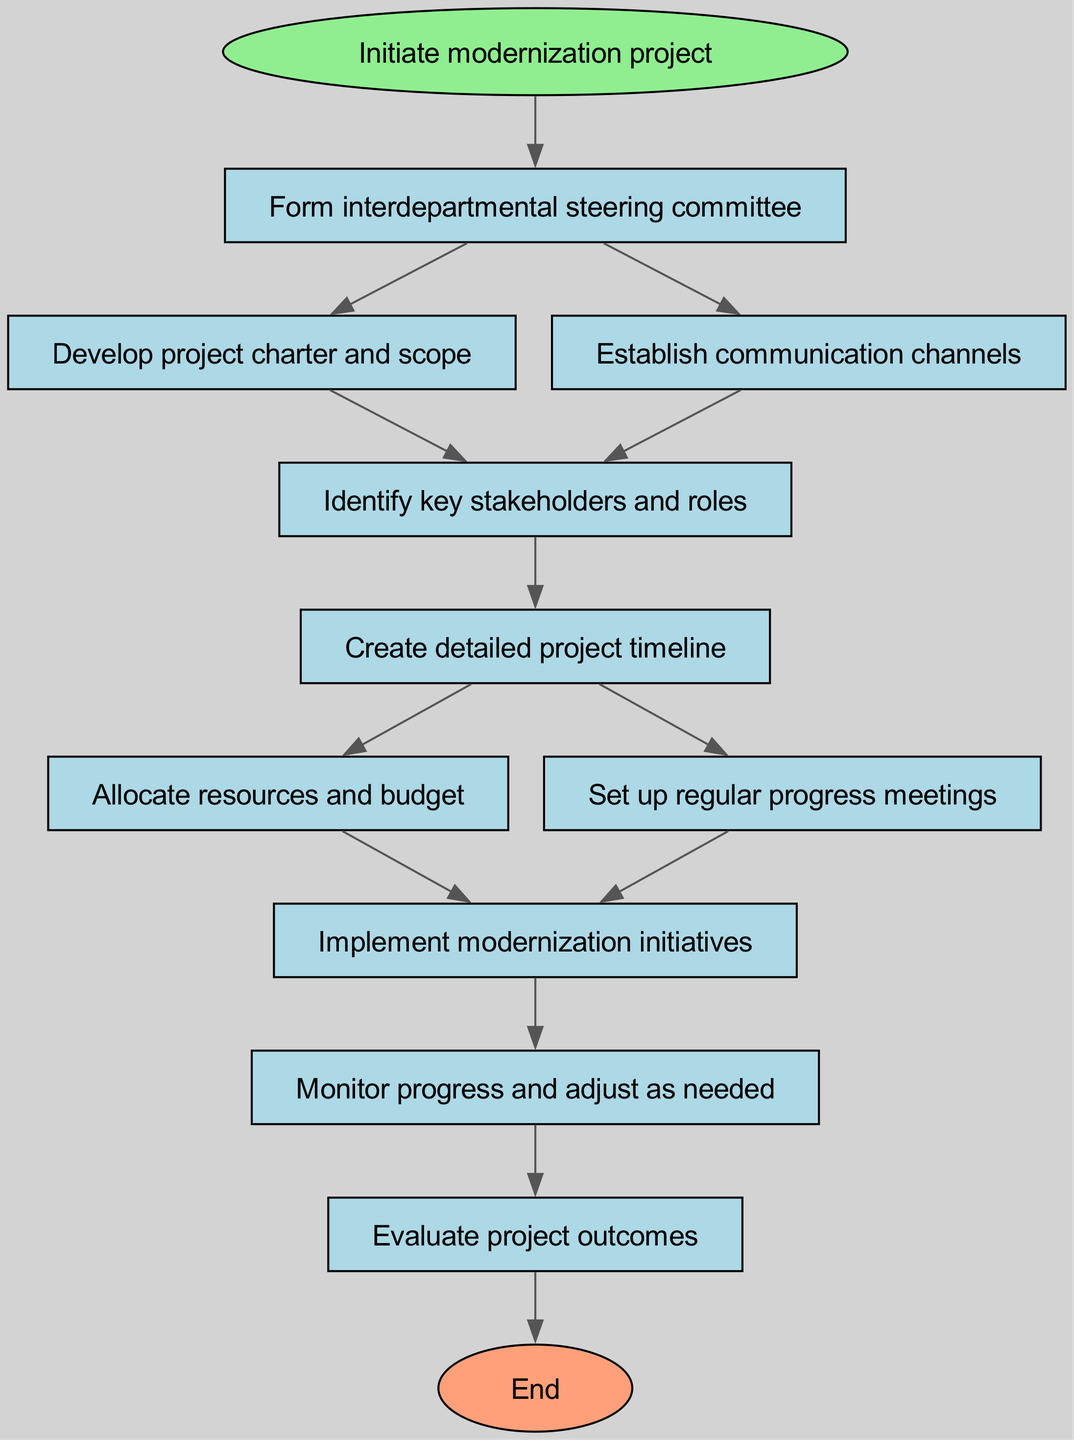What's the first step in the process? The diagram begins with the node labeled "Initiate modernization project," which represents the initial action taken in the protocol. Thus, the first step is to initiate the project.
Answer: Initiate modernization project How many nodes are in this diagram? The diagram contains a total of 10 process nodes and an additional start and end node, making it 12 nodes in total.
Answer: 12 nodes Which step follows the establishment of communication channels? According to the flowchart, the next step that follows "Establish communication channels" is "Identify key stakeholders and roles." The flow moves directly from step 3 to step 4.
Answer: Identify key stakeholders and roles What is the last action in the protocol? The last action in the diagram is represented by the node "Evaluate project outcomes," which is the final step before concluding the process.
Answer: Evaluate project outcomes How many next steps are there from creating a detailed project timeline? The diagram indicates that from the "Create detailed project timeline" node, there are two next steps, which are "Allocate resources and budget" and "Set up regular progress meetings."
Answer: 2 next steps Which nodes are directly connected from the form interdepartmental steering committee step? The "Form interdepartmental steering committee" step directly connects to two nodes: "Develop project charter and scope" and "Establish communication channels." These are the immediate next steps from this action.
Answer: Develop project charter and scope, Establish communication channels How do the regular progress meetings contribute to the project? "Set up regular progress meetings" is a step that leads to the implementation phase. These meetings are vital for maintaining oversight during "Implement modernization initiatives," ensuring the project stays on track.
Answer: Maintain oversight What is necessary before implementing modernization initiatives? Before "Implement modernization initiatives," stakeholders must "Identify key stakeholders and roles." This step is crucial for ensuring that the right people are involved in the implementation process.
Answer: Identify key stakeholders and roles If stakeholders are identified, what comes next? Once stakeholders and their roles are identified, the next step is to "Create detailed project timeline." This planning allows for structured progress through the project stages moving forward.
Answer: Create detailed project timeline 